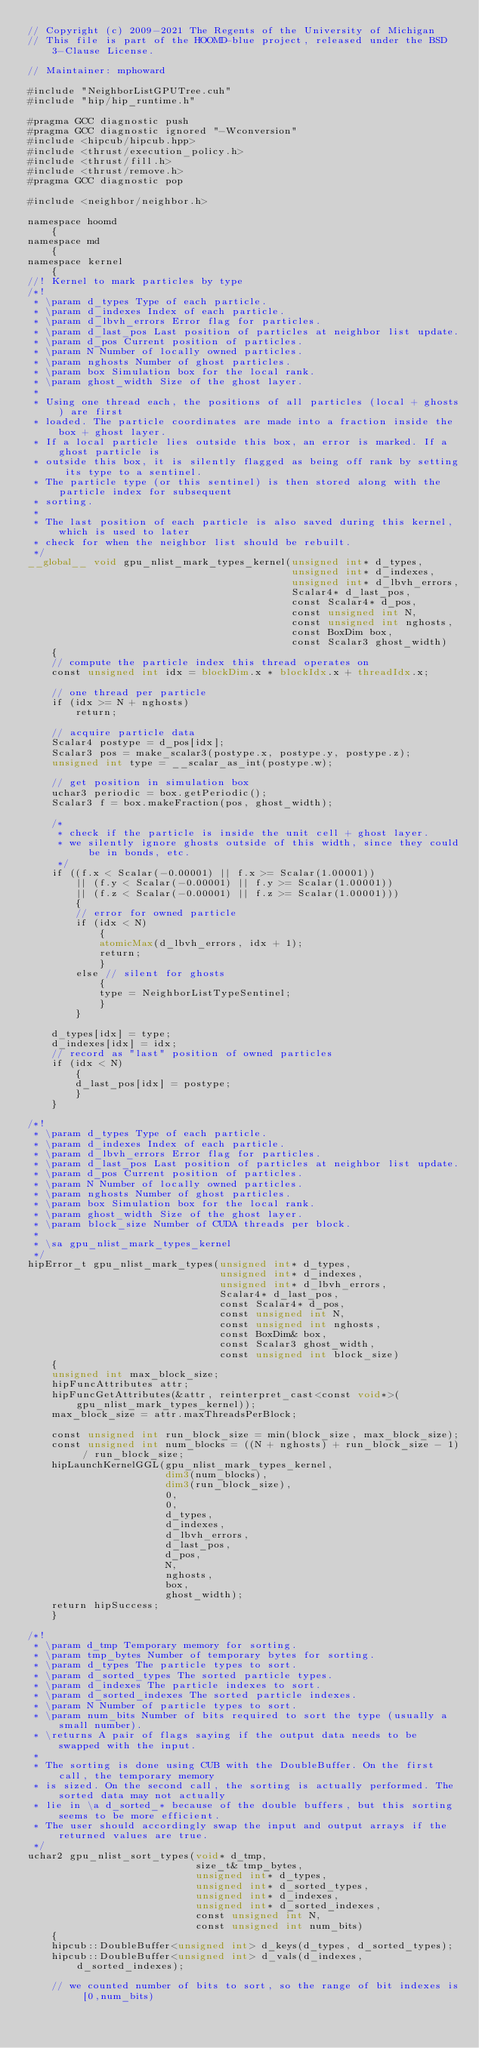Convert code to text. <code><loc_0><loc_0><loc_500><loc_500><_Cuda_>// Copyright (c) 2009-2021 The Regents of the University of Michigan
// This file is part of the HOOMD-blue project, released under the BSD 3-Clause License.

// Maintainer: mphoward

#include "NeighborListGPUTree.cuh"
#include "hip/hip_runtime.h"

#pragma GCC diagnostic push
#pragma GCC diagnostic ignored "-Wconversion"
#include <hipcub/hipcub.hpp>
#include <thrust/execution_policy.h>
#include <thrust/fill.h>
#include <thrust/remove.h>
#pragma GCC diagnostic pop

#include <neighbor/neighbor.h>

namespace hoomd
    {
namespace md
    {
namespace kernel
    {
//! Kernel to mark particles by type
/*!
 * \param d_types Type of each particle.
 * \param d_indexes Index of each particle.
 * \param d_lbvh_errors Error flag for particles.
 * \param d_last_pos Last position of particles at neighbor list update.
 * \param d_pos Current position of particles.
 * \param N Number of locally owned particles.
 * \param nghosts Number of ghost particles.
 * \param box Simulation box for the local rank.
 * \param ghost_width Size of the ghost layer.
 *
 * Using one thread each, the positions of all particles (local + ghosts) are first
 * loaded. The particle coordinates are made into a fraction inside the box + ghost layer.
 * If a local particle lies outside this box, an error is marked. If a ghost particle is
 * outside this box, it is silently flagged as being off rank by setting its type to a sentinel.
 * The particle type (or this sentinel) is then stored along with the particle index for subsequent
 * sorting.
 *
 * The last position of each particle is also saved during this kernel, which is used to later
 * check for when the neighbor list should be rebuilt.
 */
__global__ void gpu_nlist_mark_types_kernel(unsigned int* d_types,
                                            unsigned int* d_indexes,
                                            unsigned int* d_lbvh_errors,
                                            Scalar4* d_last_pos,
                                            const Scalar4* d_pos,
                                            const unsigned int N,
                                            const unsigned int nghosts,
                                            const BoxDim box,
                                            const Scalar3 ghost_width)
    {
    // compute the particle index this thread operates on
    const unsigned int idx = blockDim.x * blockIdx.x + threadIdx.x;

    // one thread per particle
    if (idx >= N + nghosts)
        return;

    // acquire particle data
    Scalar4 postype = d_pos[idx];
    Scalar3 pos = make_scalar3(postype.x, postype.y, postype.z);
    unsigned int type = __scalar_as_int(postype.w);

    // get position in simulation box
    uchar3 periodic = box.getPeriodic();
    Scalar3 f = box.makeFraction(pos, ghost_width);

    /*
     * check if the particle is inside the unit cell + ghost layer.
     * we silently ignore ghosts outside of this width, since they could be in bonds, etc.
     */
    if ((f.x < Scalar(-0.00001) || f.x >= Scalar(1.00001))
        || (f.y < Scalar(-0.00001) || f.y >= Scalar(1.00001))
        || (f.z < Scalar(-0.00001) || f.z >= Scalar(1.00001)))
        {
        // error for owned particle
        if (idx < N)
            {
            atomicMax(d_lbvh_errors, idx + 1);
            return;
            }
        else // silent for ghosts
            {
            type = NeighborListTypeSentinel;
            }
        }

    d_types[idx] = type;
    d_indexes[idx] = idx;
    // record as "last" position of owned particles
    if (idx < N)
        {
        d_last_pos[idx] = postype;
        }
    }

/*!
 * \param d_types Type of each particle.
 * \param d_indexes Index of each particle.
 * \param d_lbvh_errors Error flag for particles.
 * \param d_last_pos Last position of particles at neighbor list update.
 * \param d_pos Current position of particles.
 * \param N Number of locally owned particles.
 * \param nghosts Number of ghost particles.
 * \param box Simulation box for the local rank.
 * \param ghost_width Size of the ghost layer.
 * \param block_size Number of CUDA threads per block.
 *
 * \sa gpu_nlist_mark_types_kernel
 */
hipError_t gpu_nlist_mark_types(unsigned int* d_types,
                                unsigned int* d_indexes,
                                unsigned int* d_lbvh_errors,
                                Scalar4* d_last_pos,
                                const Scalar4* d_pos,
                                const unsigned int N,
                                const unsigned int nghosts,
                                const BoxDim& box,
                                const Scalar3 ghost_width,
                                const unsigned int block_size)
    {
    unsigned int max_block_size;
    hipFuncAttributes attr;
    hipFuncGetAttributes(&attr, reinterpret_cast<const void*>(gpu_nlist_mark_types_kernel));
    max_block_size = attr.maxThreadsPerBlock;

    const unsigned int run_block_size = min(block_size, max_block_size);
    const unsigned int num_blocks = ((N + nghosts) + run_block_size - 1) / run_block_size;
    hipLaunchKernelGGL(gpu_nlist_mark_types_kernel,
                       dim3(num_blocks),
                       dim3(run_block_size),
                       0,
                       0,
                       d_types,
                       d_indexes,
                       d_lbvh_errors,
                       d_last_pos,
                       d_pos,
                       N,
                       nghosts,
                       box,
                       ghost_width);
    return hipSuccess;
    }

/*!
 * \param d_tmp Temporary memory for sorting.
 * \param tmp_bytes Number of temporary bytes for sorting.
 * \param d_types The particle types to sort.
 * \param d_sorted_types The sorted particle types.
 * \param d_indexes The particle indexes to sort.
 * \param d_sorted_indexes The sorted particle indexes.
 * \param N Number of particle types to sort.
 * \param num_bits Number of bits required to sort the type (usually a small number).
 * \returns A pair of flags saying if the output data needs to be swapped with the input.
 *
 * The sorting is done using CUB with the DoubleBuffer. On the first call, the temporary memory
 * is sized. On the second call, the sorting is actually performed. The sorted data may not actually
 * lie in \a d_sorted_* because of the double buffers, but this sorting seems to be more efficient.
 * The user should accordingly swap the input and output arrays if the returned values are true.
 */
uchar2 gpu_nlist_sort_types(void* d_tmp,
                            size_t& tmp_bytes,
                            unsigned int* d_types,
                            unsigned int* d_sorted_types,
                            unsigned int* d_indexes,
                            unsigned int* d_sorted_indexes,
                            const unsigned int N,
                            const unsigned int num_bits)
    {
    hipcub::DoubleBuffer<unsigned int> d_keys(d_types, d_sorted_types);
    hipcub::DoubleBuffer<unsigned int> d_vals(d_indexes, d_sorted_indexes);

    // we counted number of bits to sort, so the range of bit indexes is [0,num_bits)</code> 